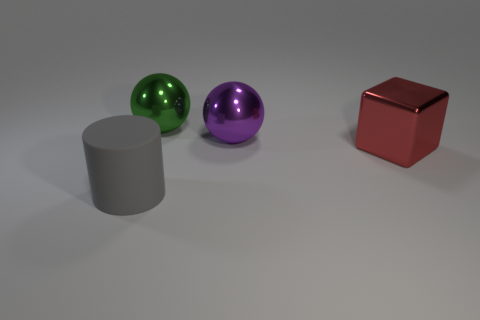Add 1 large metallic spheres. How many objects exist? 5 Subtract all purple balls. How many balls are left? 1 Subtract 0 blue cylinders. How many objects are left? 4 Subtract all cylinders. How many objects are left? 3 Subtract 1 cylinders. How many cylinders are left? 0 Subtract all brown cylinders. Subtract all gray balls. How many cylinders are left? 1 Subtract all cylinders. Subtract all purple balls. How many objects are left? 2 Add 4 large gray cylinders. How many large gray cylinders are left? 5 Add 1 matte cylinders. How many matte cylinders exist? 2 